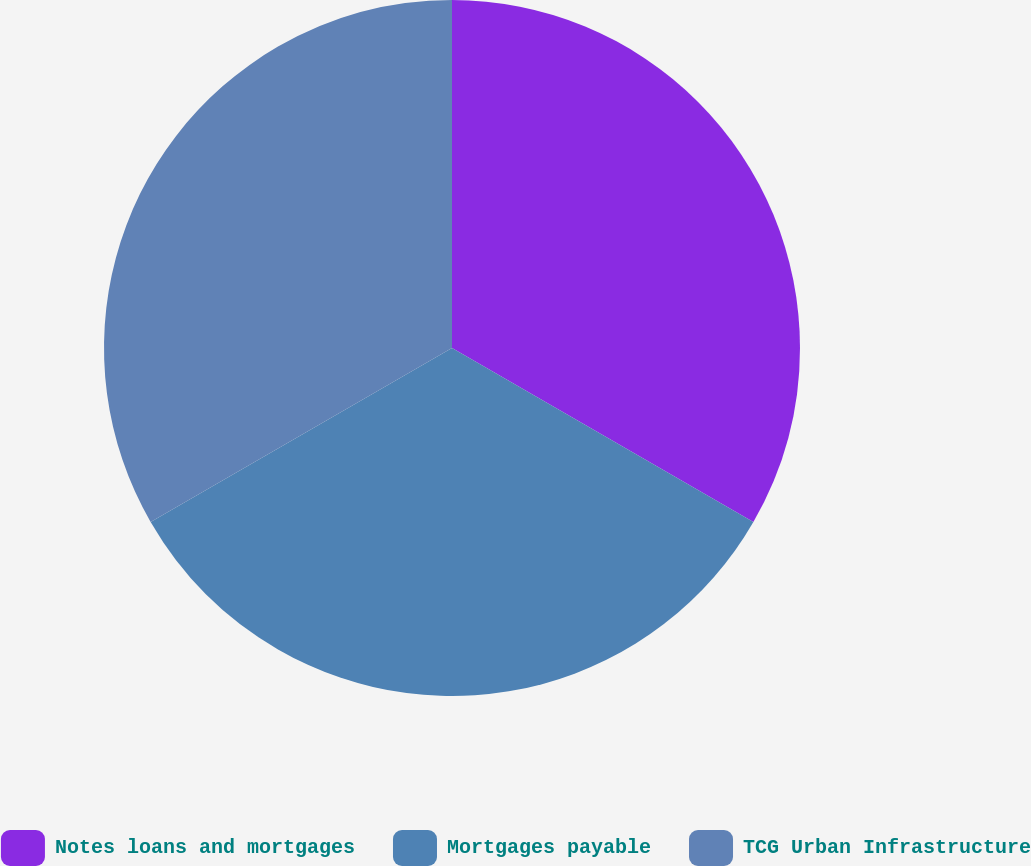<chart> <loc_0><loc_0><loc_500><loc_500><pie_chart><fcel>Notes loans and mortgages<fcel>Mortgages payable<fcel>TCG Urban Infrastructure<nl><fcel>33.33%<fcel>33.33%<fcel>33.33%<nl></chart> 